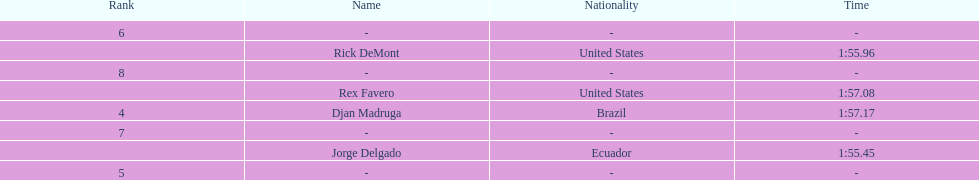What come after rex f. Djan Madruga. 